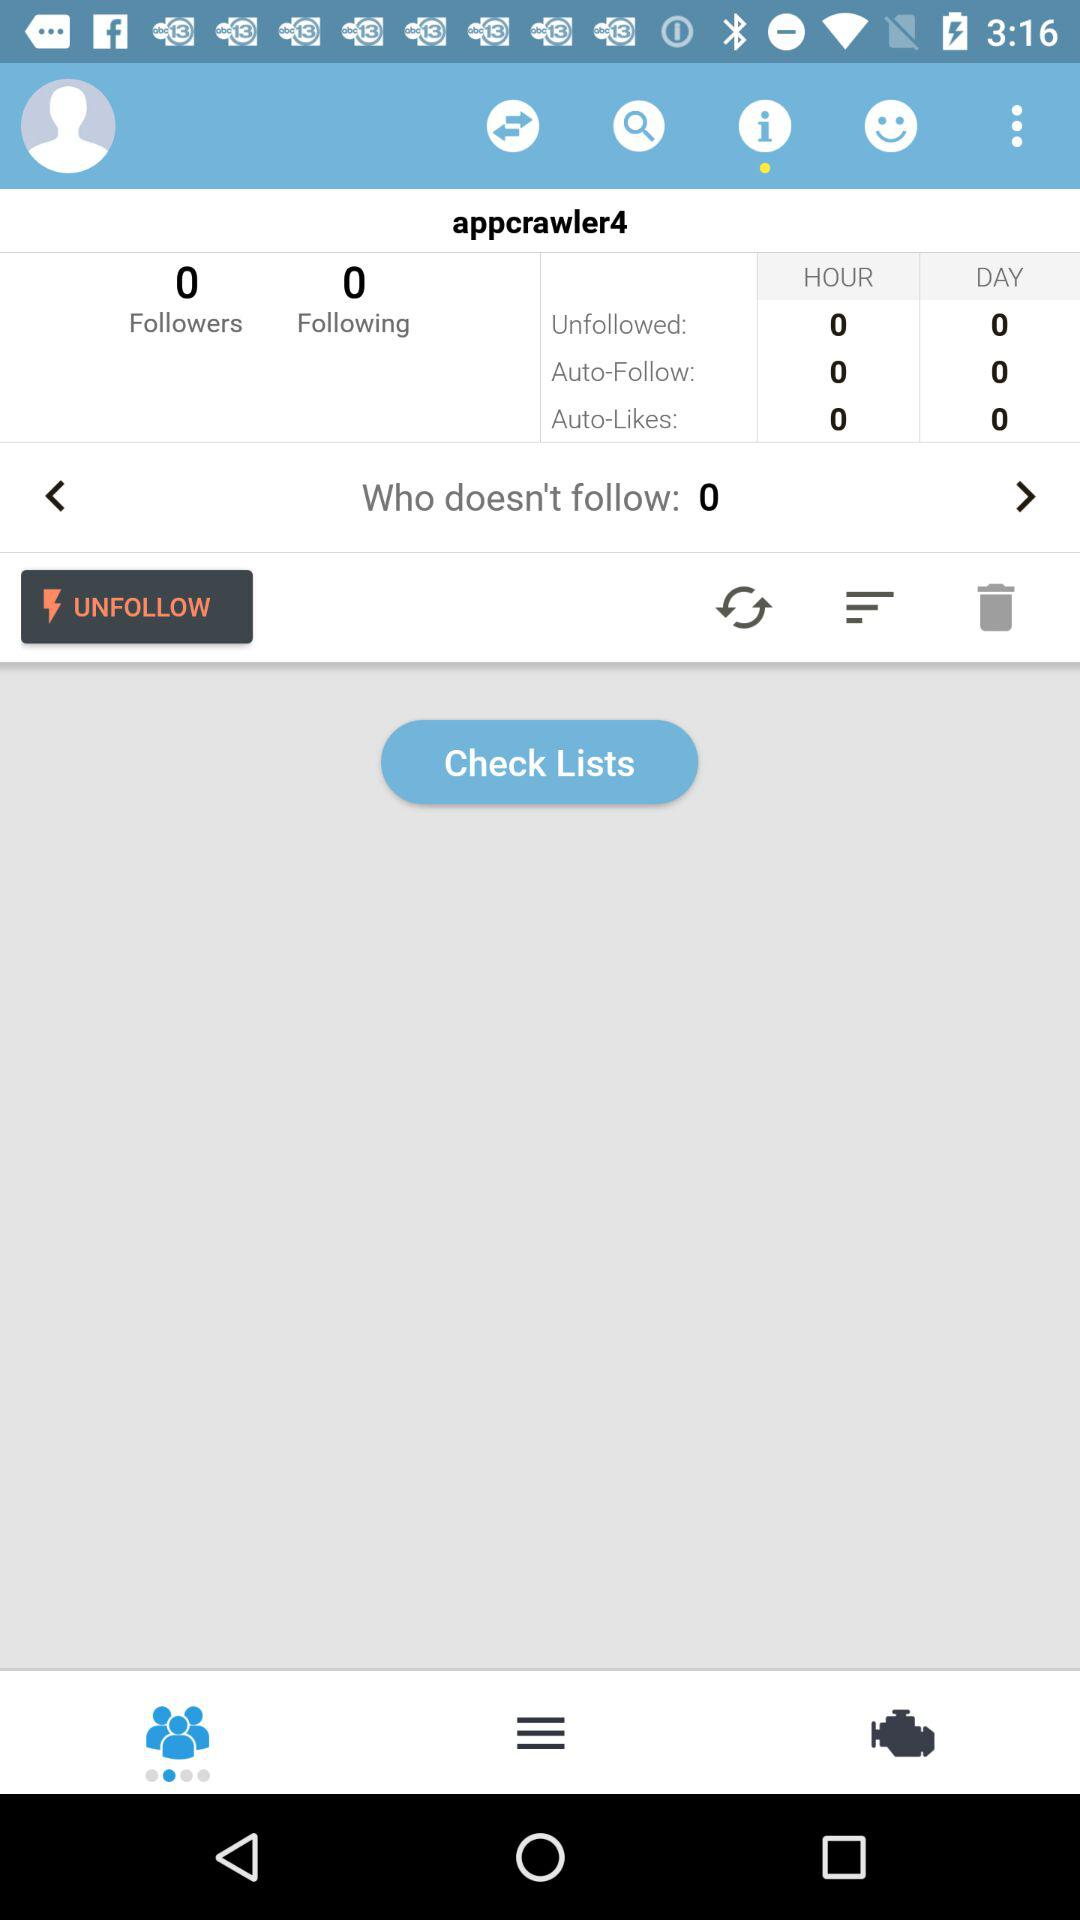How many auto-likes are there in an hour? There are 0 auto-likes in an hour. 